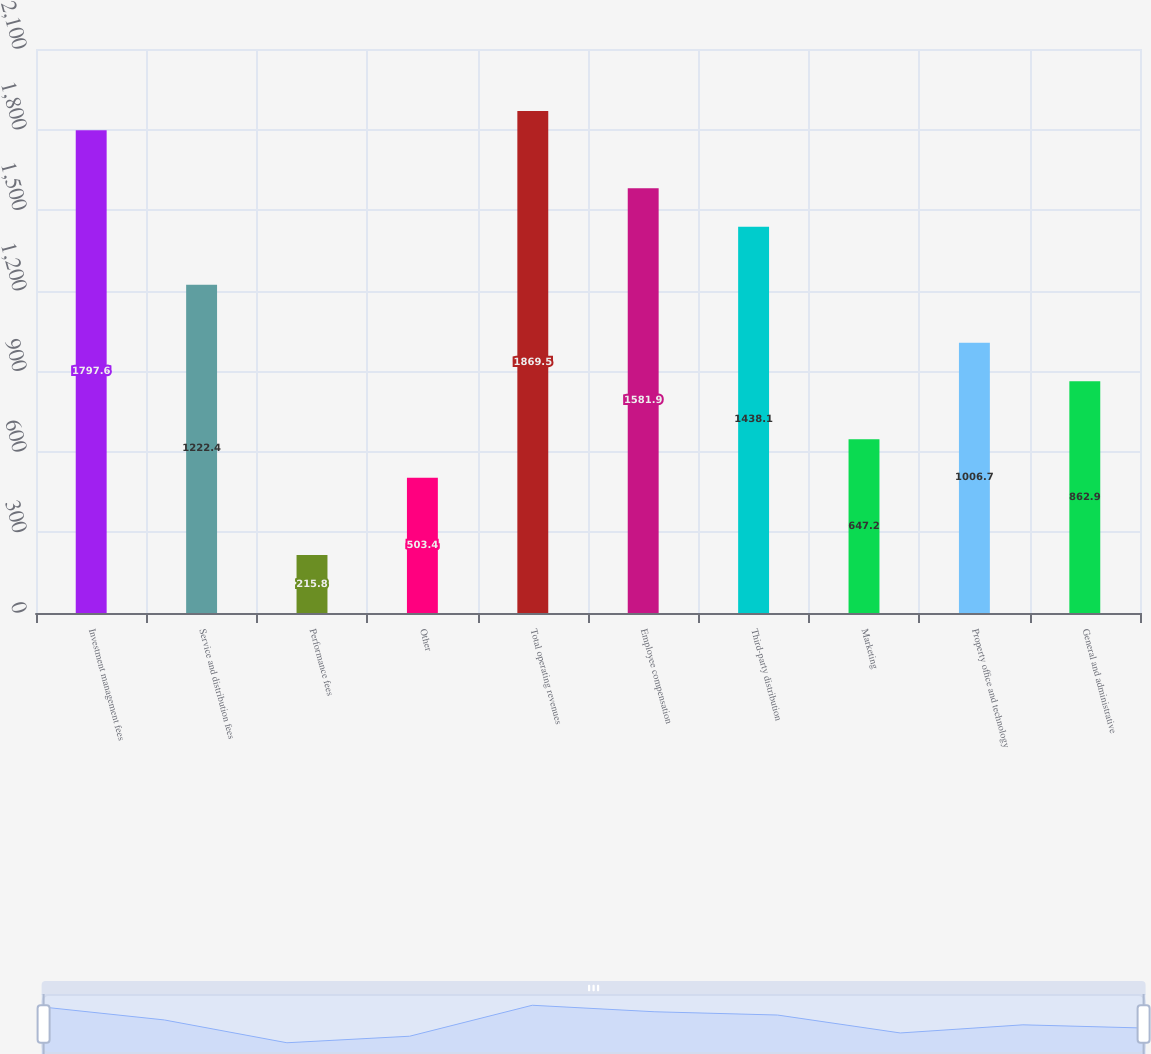Convert chart. <chart><loc_0><loc_0><loc_500><loc_500><bar_chart><fcel>Investment management fees<fcel>Service and distribution fees<fcel>Performance fees<fcel>Other<fcel>Total operating revenues<fcel>Employee compensation<fcel>Third-party distribution<fcel>Marketing<fcel>Property office and technology<fcel>General and administrative<nl><fcel>1797.6<fcel>1222.4<fcel>215.8<fcel>503.4<fcel>1869.5<fcel>1581.9<fcel>1438.1<fcel>647.2<fcel>1006.7<fcel>862.9<nl></chart> 